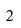<formula> <loc_0><loc_0><loc_500><loc_500>2</formula> 